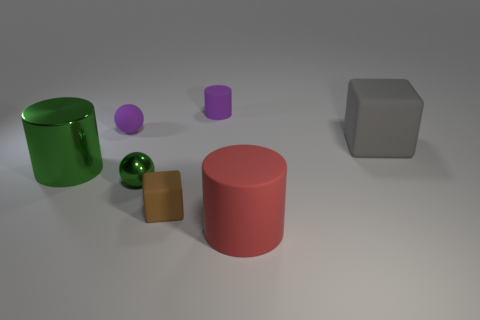The big metallic object that is the same color as the metallic ball is what shape?
Your answer should be very brief. Cylinder. Are there an equal number of big matte cubes in front of the gray object and things?
Your response must be concise. No. What size is the sphere behind the big green metal thing?
Your answer should be very brief. Small. How many small things are either blue shiny cylinders or metallic things?
Offer a very short reply. 1. The tiny rubber object that is the same shape as the small green metallic object is what color?
Give a very brief answer. Purple. Do the gray object and the brown thing have the same size?
Keep it short and to the point. No. What number of things are tiny purple cylinders or large red cylinders right of the small green metallic object?
Give a very brief answer. 2. There is a cylinder on the left side of the rubber block in front of the green metallic ball; what is its color?
Your answer should be compact. Green. Does the matte thing that is to the right of the big red rubber object have the same color as the small metal sphere?
Ensure brevity in your answer.  No. There is a tiny brown block that is to the left of the large gray object; what is its material?
Provide a succinct answer. Rubber. 